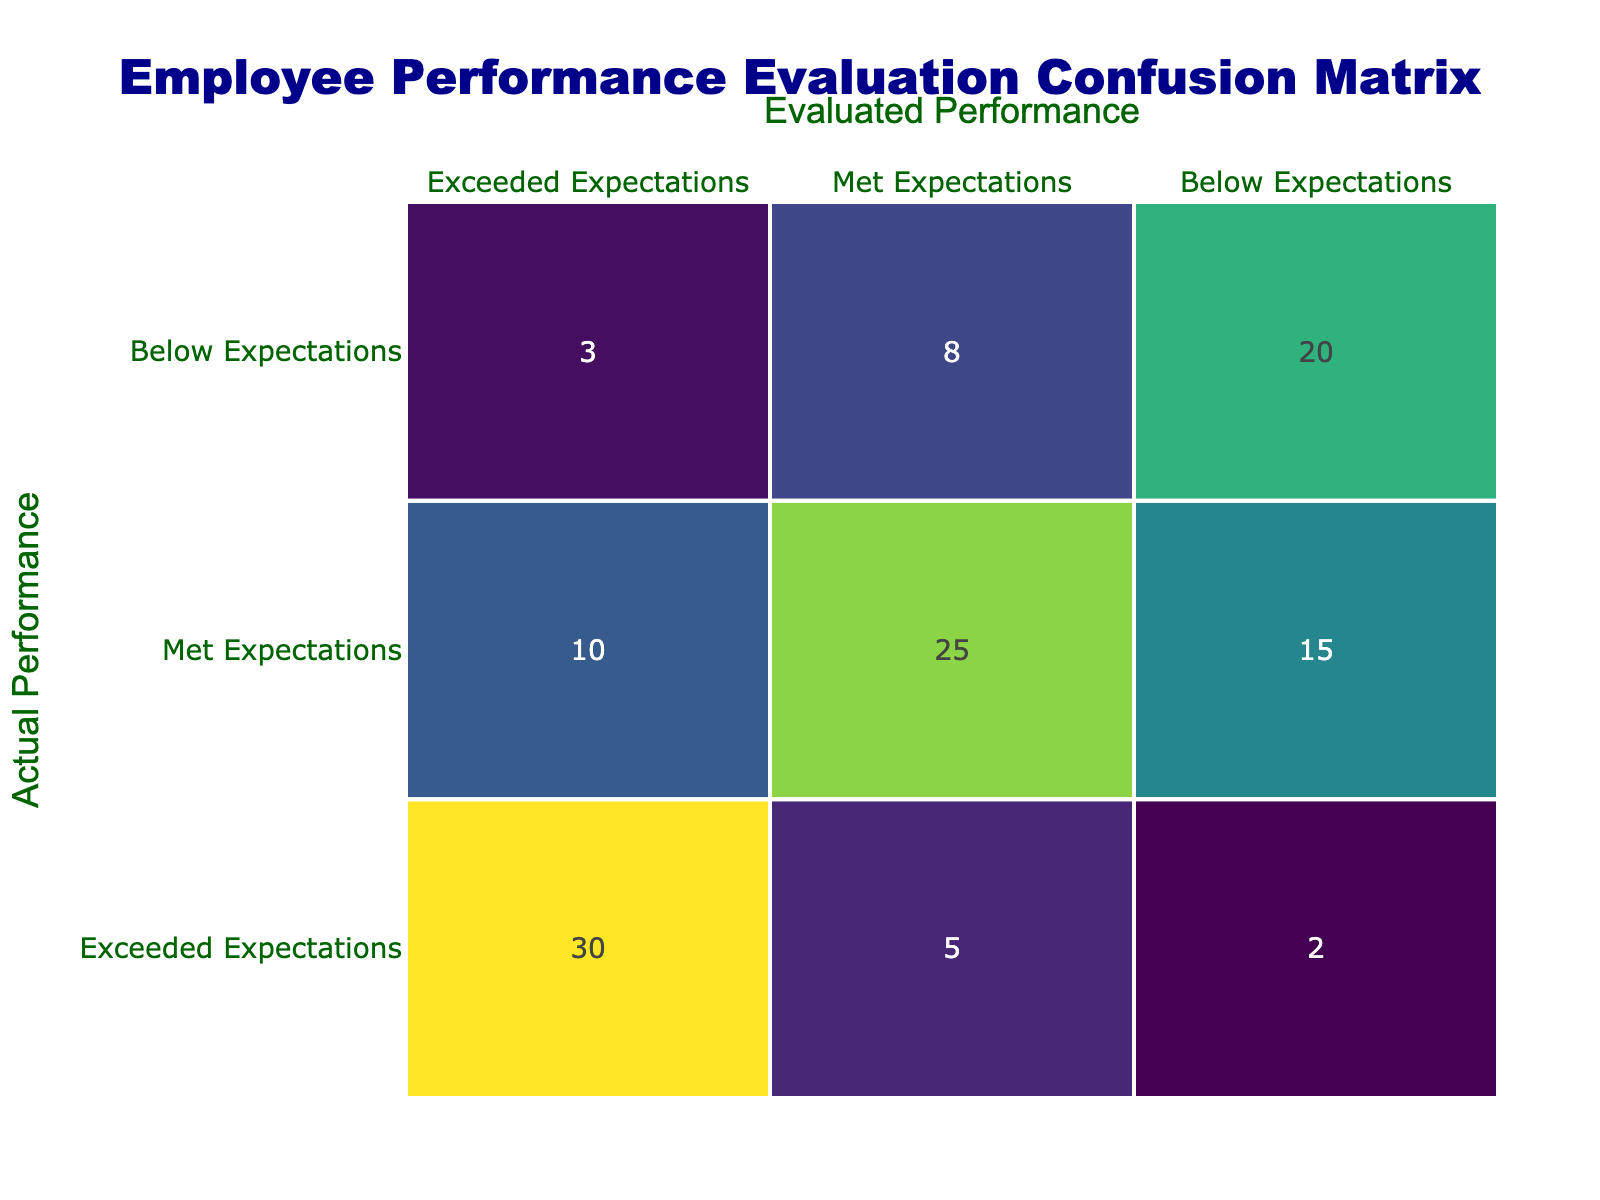What is the total number of employees evaluated as "Exceeded Expectations"? To find this, we look at the "Exceeded Expectations" column in the confusion matrix. The total is calculated by summing the values in this column: 30 (actual exceed) + 10 (met as exceed) + 3 (below as exceed) = 43.
Answer: 43 How many employees were incorrectly evaluated as "Below Expectations" but actually "Exceeded Expectations"? We check the cell located in the row for "Exceeded Expectations" and the column for "Below Expectations" which shows 2. This represents the number of employees who were actual exceeders but were evaluated incorrectly.
Answer: 2 What percentage of employees who actually met expectations were evaluated correctly? To calculate this, we need the number of correctly evaluated employees (25) divided by the total number who actually met expectations (10 + 25 + 15 = 50). The percentage is (25/50) * 100 = 50%.
Answer: 50% Is it true that more employees were evaluated as "Met Expectations" than "Exceeded Expectations"? We can verify this by comparing the total number of evaluations in both categories. Evaluated as "Met Expectations": 10 (actual exceed) + 25 (actual met) + 15 (actual below) = 50. Evaluated as "Exceeded Expectations": 30 + 5 + 2 = 37. Since 50 > 37, the statement is true.
Answer: Yes How many employees were classified as "Below Expectations" but actually "Met Expectations"? To find this, we look at the value at the intersection of the "Met Expectations" row and "Below Expectations" column, which is 15. This indicates the number of employees who were incorrectly classified.
Answer: 15 What is the difference between the number of employees evaluated as "Exceeded Expectations" and those evaluated as "Below Expectations"? For "Exceeded Expectations", the total is 43 (from the previous calculations), and for "Below Expectations", the total is 3 (3 + 8 + 20 = 31). The difference is 43 - 31 = 12.
Answer: 12 What is the combined total of employees evaluated as "Met Expectations" and correctly rated as "Exceeded Expectations"? From the confusion matrix, 25 employees met expectations were evaluated correctly and 30 exceeded expectations were evaluated correctly. The combined total is 25 + 30 = 55.
Answer: 55 How many employees were evaluated wrongly in total? We find the inaccuracies in the matrix. The wrong evaluations can be calculated by adding: 5 (met evaluated as exceed) + 10 (exceed evaluated as met) + 15 (below evaluated as met) + 3 (exceed evaluated as below) + 8 (met evaluated as below) = 41. So the total number of wrongly evaluated employees is 41.
Answer: 41 